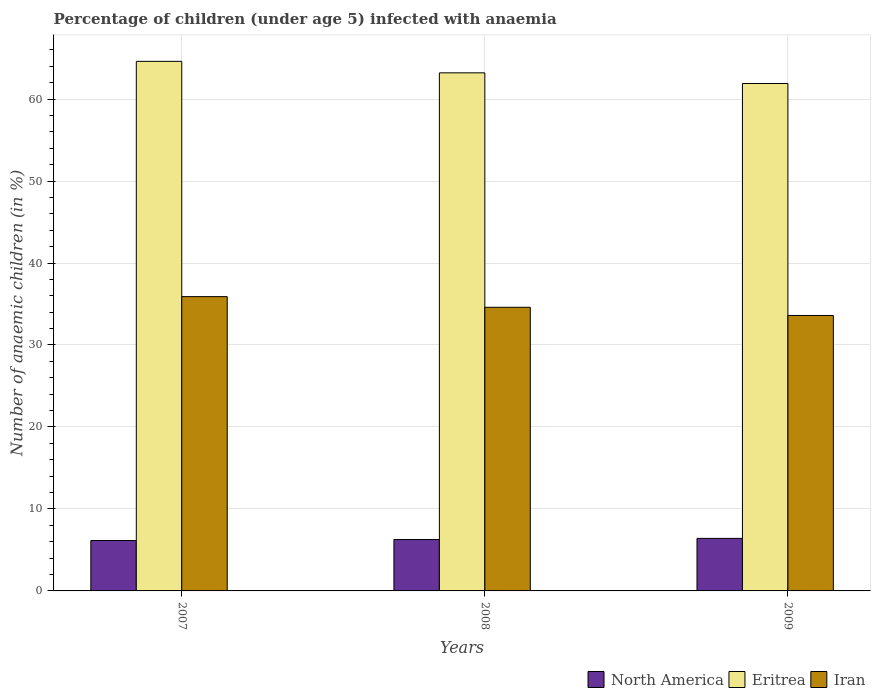How many different coloured bars are there?
Provide a succinct answer. 3. How many groups of bars are there?
Provide a succinct answer. 3. Are the number of bars per tick equal to the number of legend labels?
Give a very brief answer. Yes. Are the number of bars on each tick of the X-axis equal?
Provide a short and direct response. Yes. How many bars are there on the 1st tick from the right?
Ensure brevity in your answer.  3. In how many cases, is the number of bars for a given year not equal to the number of legend labels?
Provide a succinct answer. 0. What is the percentage of children infected with anaemia in in North America in 2007?
Give a very brief answer. 6.15. Across all years, what is the maximum percentage of children infected with anaemia in in Eritrea?
Provide a short and direct response. 64.6. Across all years, what is the minimum percentage of children infected with anaemia in in Eritrea?
Provide a succinct answer. 61.9. In which year was the percentage of children infected with anaemia in in North America maximum?
Make the answer very short. 2009. In which year was the percentage of children infected with anaemia in in North America minimum?
Keep it short and to the point. 2007. What is the total percentage of children infected with anaemia in in Eritrea in the graph?
Your answer should be compact. 189.7. What is the difference between the percentage of children infected with anaemia in in North America in 2007 and that in 2009?
Ensure brevity in your answer.  -0.26. What is the difference between the percentage of children infected with anaemia in in Eritrea in 2007 and the percentage of children infected with anaemia in in North America in 2009?
Provide a short and direct response. 58.19. What is the average percentage of children infected with anaemia in in Iran per year?
Your answer should be compact. 34.7. In the year 2008, what is the difference between the percentage of children infected with anaemia in in Eritrea and percentage of children infected with anaemia in in Iran?
Provide a short and direct response. 28.6. In how many years, is the percentage of children infected with anaemia in in Eritrea greater than 50 %?
Your answer should be very brief. 3. What is the ratio of the percentage of children infected with anaemia in in North America in 2007 to that in 2009?
Offer a terse response. 0.96. Is the percentage of children infected with anaemia in in North America in 2007 less than that in 2008?
Give a very brief answer. Yes. What is the difference between the highest and the second highest percentage of children infected with anaemia in in Iran?
Provide a succinct answer. 1.3. What is the difference between the highest and the lowest percentage of children infected with anaemia in in North America?
Make the answer very short. 0.26. What does the 2nd bar from the left in 2008 represents?
Your response must be concise. Eritrea. Is it the case that in every year, the sum of the percentage of children infected with anaemia in in Eritrea and percentage of children infected with anaemia in in Iran is greater than the percentage of children infected with anaemia in in North America?
Ensure brevity in your answer.  Yes. How many bars are there?
Your response must be concise. 9. How many years are there in the graph?
Provide a succinct answer. 3. What is the difference between two consecutive major ticks on the Y-axis?
Your answer should be compact. 10. Does the graph contain grids?
Keep it short and to the point. Yes. Where does the legend appear in the graph?
Keep it short and to the point. Bottom right. How many legend labels are there?
Provide a succinct answer. 3. What is the title of the graph?
Your answer should be compact. Percentage of children (under age 5) infected with anaemia. Does "Guam" appear as one of the legend labels in the graph?
Offer a terse response. No. What is the label or title of the Y-axis?
Provide a succinct answer. Number of anaemic children (in %). What is the Number of anaemic children (in %) of North America in 2007?
Make the answer very short. 6.15. What is the Number of anaemic children (in %) in Eritrea in 2007?
Give a very brief answer. 64.6. What is the Number of anaemic children (in %) of Iran in 2007?
Provide a short and direct response. 35.9. What is the Number of anaemic children (in %) of North America in 2008?
Your answer should be very brief. 6.27. What is the Number of anaemic children (in %) in Eritrea in 2008?
Offer a terse response. 63.2. What is the Number of anaemic children (in %) of Iran in 2008?
Offer a very short reply. 34.6. What is the Number of anaemic children (in %) of North America in 2009?
Provide a succinct answer. 6.41. What is the Number of anaemic children (in %) of Eritrea in 2009?
Provide a short and direct response. 61.9. What is the Number of anaemic children (in %) in Iran in 2009?
Make the answer very short. 33.6. Across all years, what is the maximum Number of anaemic children (in %) in North America?
Your answer should be compact. 6.41. Across all years, what is the maximum Number of anaemic children (in %) of Eritrea?
Your answer should be compact. 64.6. Across all years, what is the maximum Number of anaemic children (in %) of Iran?
Your answer should be compact. 35.9. Across all years, what is the minimum Number of anaemic children (in %) of North America?
Your response must be concise. 6.15. Across all years, what is the minimum Number of anaemic children (in %) of Eritrea?
Your response must be concise. 61.9. Across all years, what is the minimum Number of anaemic children (in %) of Iran?
Make the answer very short. 33.6. What is the total Number of anaemic children (in %) of North America in the graph?
Give a very brief answer. 18.83. What is the total Number of anaemic children (in %) in Eritrea in the graph?
Your response must be concise. 189.7. What is the total Number of anaemic children (in %) in Iran in the graph?
Give a very brief answer. 104.1. What is the difference between the Number of anaemic children (in %) of North America in 2007 and that in 2008?
Offer a terse response. -0.12. What is the difference between the Number of anaemic children (in %) in Eritrea in 2007 and that in 2008?
Your response must be concise. 1.4. What is the difference between the Number of anaemic children (in %) in North America in 2007 and that in 2009?
Keep it short and to the point. -0.26. What is the difference between the Number of anaemic children (in %) of North America in 2008 and that in 2009?
Offer a very short reply. -0.14. What is the difference between the Number of anaemic children (in %) of Iran in 2008 and that in 2009?
Your answer should be very brief. 1. What is the difference between the Number of anaemic children (in %) of North America in 2007 and the Number of anaemic children (in %) of Eritrea in 2008?
Your response must be concise. -57.05. What is the difference between the Number of anaemic children (in %) of North America in 2007 and the Number of anaemic children (in %) of Iran in 2008?
Ensure brevity in your answer.  -28.45. What is the difference between the Number of anaemic children (in %) of North America in 2007 and the Number of anaemic children (in %) of Eritrea in 2009?
Offer a very short reply. -55.75. What is the difference between the Number of anaemic children (in %) in North America in 2007 and the Number of anaemic children (in %) in Iran in 2009?
Ensure brevity in your answer.  -27.45. What is the difference between the Number of anaemic children (in %) in Eritrea in 2007 and the Number of anaemic children (in %) in Iran in 2009?
Your response must be concise. 31. What is the difference between the Number of anaemic children (in %) in North America in 2008 and the Number of anaemic children (in %) in Eritrea in 2009?
Offer a very short reply. -55.63. What is the difference between the Number of anaemic children (in %) in North America in 2008 and the Number of anaemic children (in %) in Iran in 2009?
Your answer should be compact. -27.33. What is the difference between the Number of anaemic children (in %) of Eritrea in 2008 and the Number of anaemic children (in %) of Iran in 2009?
Provide a succinct answer. 29.6. What is the average Number of anaemic children (in %) in North America per year?
Your response must be concise. 6.28. What is the average Number of anaemic children (in %) of Eritrea per year?
Offer a terse response. 63.23. What is the average Number of anaemic children (in %) in Iran per year?
Your answer should be very brief. 34.7. In the year 2007, what is the difference between the Number of anaemic children (in %) of North America and Number of anaemic children (in %) of Eritrea?
Offer a terse response. -58.45. In the year 2007, what is the difference between the Number of anaemic children (in %) in North America and Number of anaemic children (in %) in Iran?
Offer a very short reply. -29.75. In the year 2007, what is the difference between the Number of anaemic children (in %) of Eritrea and Number of anaemic children (in %) of Iran?
Your response must be concise. 28.7. In the year 2008, what is the difference between the Number of anaemic children (in %) in North America and Number of anaemic children (in %) in Eritrea?
Give a very brief answer. -56.93. In the year 2008, what is the difference between the Number of anaemic children (in %) in North America and Number of anaemic children (in %) in Iran?
Offer a very short reply. -28.33. In the year 2008, what is the difference between the Number of anaemic children (in %) in Eritrea and Number of anaemic children (in %) in Iran?
Offer a very short reply. 28.6. In the year 2009, what is the difference between the Number of anaemic children (in %) in North America and Number of anaemic children (in %) in Eritrea?
Make the answer very short. -55.49. In the year 2009, what is the difference between the Number of anaemic children (in %) of North America and Number of anaemic children (in %) of Iran?
Provide a short and direct response. -27.19. In the year 2009, what is the difference between the Number of anaemic children (in %) of Eritrea and Number of anaemic children (in %) of Iran?
Give a very brief answer. 28.3. What is the ratio of the Number of anaemic children (in %) of North America in 2007 to that in 2008?
Provide a short and direct response. 0.98. What is the ratio of the Number of anaemic children (in %) in Eritrea in 2007 to that in 2008?
Keep it short and to the point. 1.02. What is the ratio of the Number of anaemic children (in %) in Iran in 2007 to that in 2008?
Your answer should be compact. 1.04. What is the ratio of the Number of anaemic children (in %) in North America in 2007 to that in 2009?
Provide a short and direct response. 0.96. What is the ratio of the Number of anaemic children (in %) of Eritrea in 2007 to that in 2009?
Provide a short and direct response. 1.04. What is the ratio of the Number of anaemic children (in %) in Iran in 2007 to that in 2009?
Ensure brevity in your answer.  1.07. What is the ratio of the Number of anaemic children (in %) in North America in 2008 to that in 2009?
Ensure brevity in your answer.  0.98. What is the ratio of the Number of anaemic children (in %) of Iran in 2008 to that in 2009?
Provide a short and direct response. 1.03. What is the difference between the highest and the second highest Number of anaemic children (in %) of North America?
Your answer should be very brief. 0.14. What is the difference between the highest and the second highest Number of anaemic children (in %) in Eritrea?
Provide a succinct answer. 1.4. What is the difference between the highest and the lowest Number of anaemic children (in %) in North America?
Your answer should be very brief. 0.26. What is the difference between the highest and the lowest Number of anaemic children (in %) of Iran?
Make the answer very short. 2.3. 